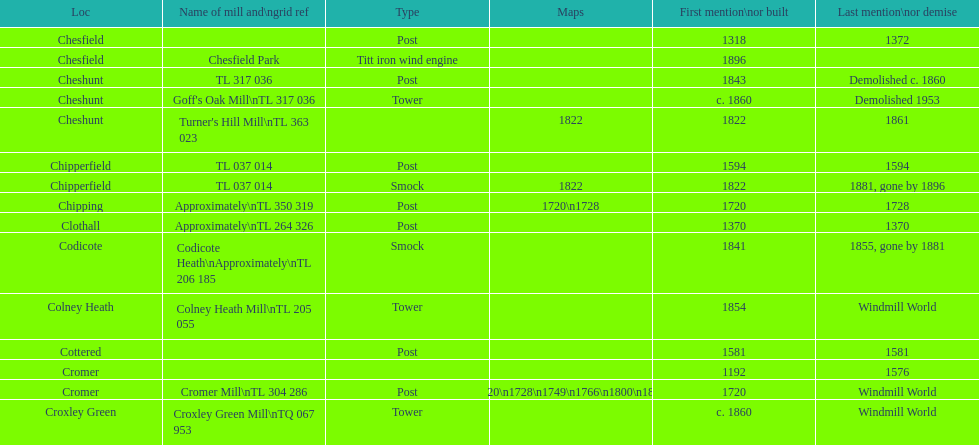How many locations have no photograph? 14. 